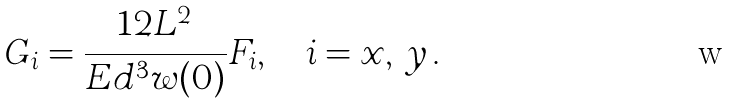<formula> <loc_0><loc_0><loc_500><loc_500>G _ { i } = \frac { 1 2 L ^ { 2 } } { E d ^ { 3 } w ( 0 ) } F _ { i } , \quad i = x , \, y \, .</formula> 